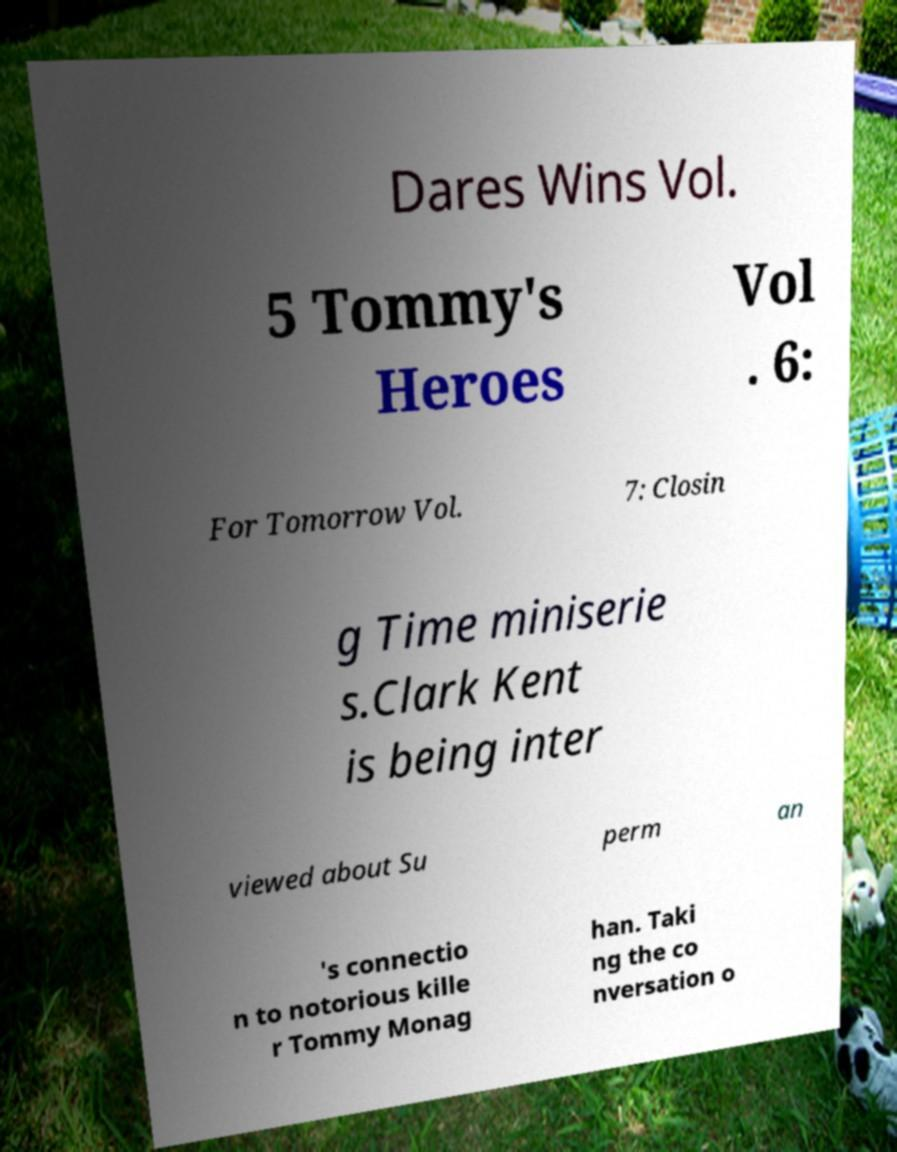Please identify and transcribe the text found in this image. Dares Wins Vol. 5 Tommy's Heroes Vol . 6: For Tomorrow Vol. 7: Closin g Time miniserie s.Clark Kent is being inter viewed about Su perm an 's connectio n to notorious kille r Tommy Monag han. Taki ng the co nversation o 